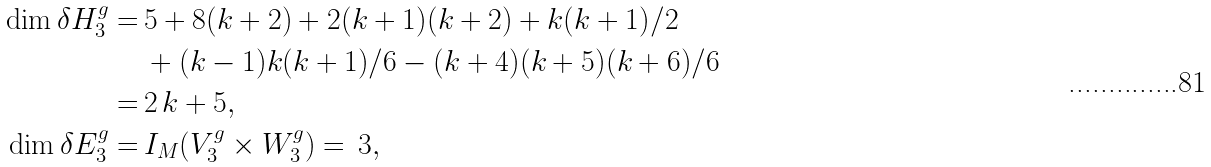Convert formula to latex. <formula><loc_0><loc_0><loc_500><loc_500>\dim \delta H _ { 3 } ^ { g } = & \, 5 + 8 ( k + 2 ) + 2 ( k + 1 ) ( k + 2 ) + k ( k + 1 ) / 2 \\ & \, + { ( k - 1 ) k ( k + 1 ) } / { 6 } - { ( k + 4 ) ( k + 5 ) ( k + 6 ) } / { 6 } \\ = & \, 2 \, k + 5 , \\ \dim \delta E _ { 3 } ^ { g } = & \, I _ { M } ( V _ { 3 } ^ { g } \times W _ { 3 } ^ { g } ) = \, 3 ,</formula> 